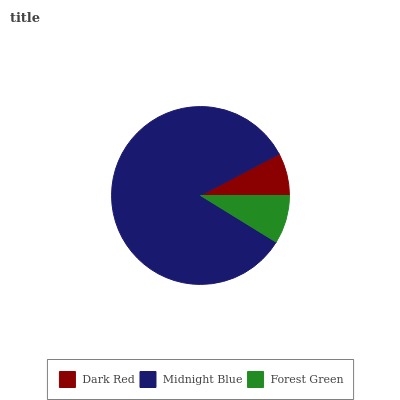Is Dark Red the minimum?
Answer yes or no. Yes. Is Midnight Blue the maximum?
Answer yes or no. Yes. Is Forest Green the minimum?
Answer yes or no. No. Is Forest Green the maximum?
Answer yes or no. No. Is Midnight Blue greater than Forest Green?
Answer yes or no. Yes. Is Forest Green less than Midnight Blue?
Answer yes or no. Yes. Is Forest Green greater than Midnight Blue?
Answer yes or no. No. Is Midnight Blue less than Forest Green?
Answer yes or no. No. Is Forest Green the high median?
Answer yes or no. Yes. Is Forest Green the low median?
Answer yes or no. Yes. Is Midnight Blue the high median?
Answer yes or no. No. Is Dark Red the low median?
Answer yes or no. No. 